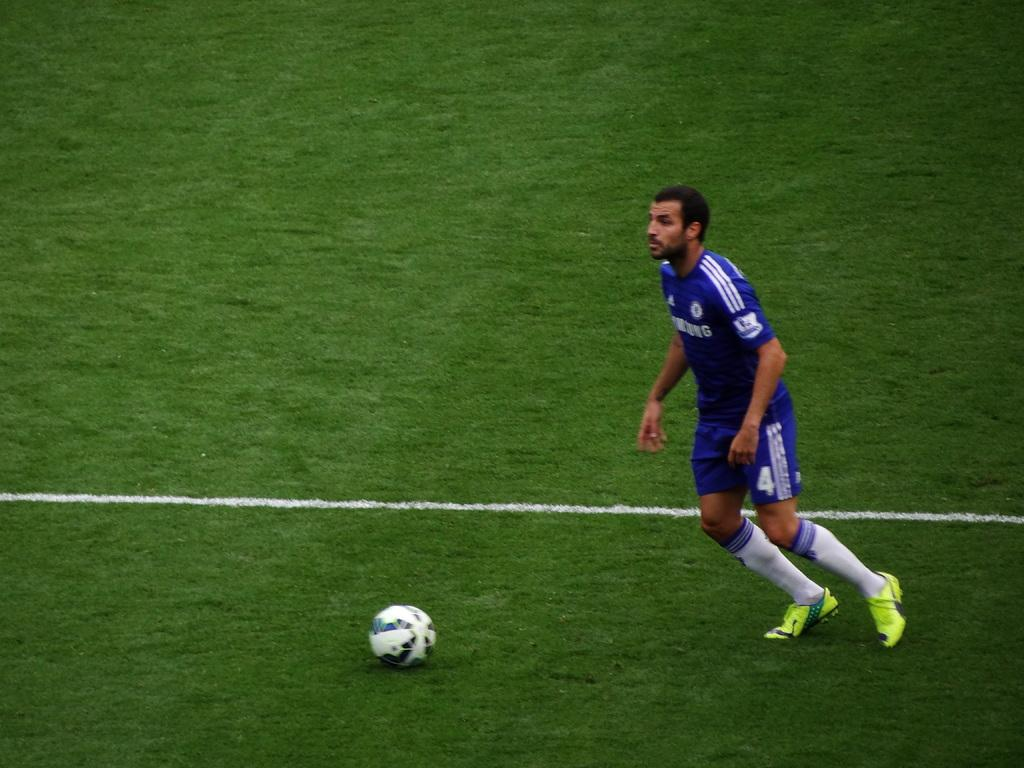<image>
Describe the image concisely. Player number 4 in a blue uniform readies to hit the ball. 